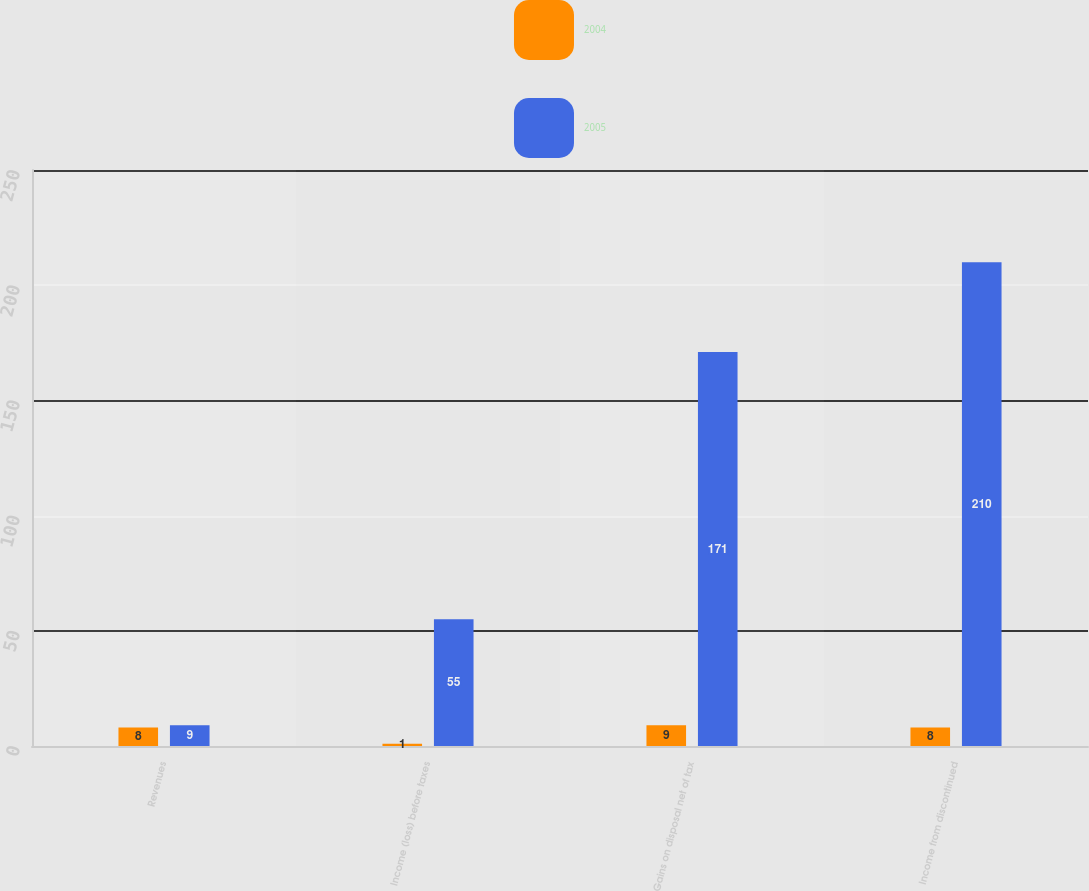Convert chart to OTSL. <chart><loc_0><loc_0><loc_500><loc_500><stacked_bar_chart><ecel><fcel>Revenues<fcel>Income (loss) before taxes<fcel>Gains on disposal net of tax<fcel>Income from discontinued<nl><fcel>2004<fcel>8<fcel>1<fcel>9<fcel>8<nl><fcel>2005<fcel>9<fcel>55<fcel>171<fcel>210<nl></chart> 